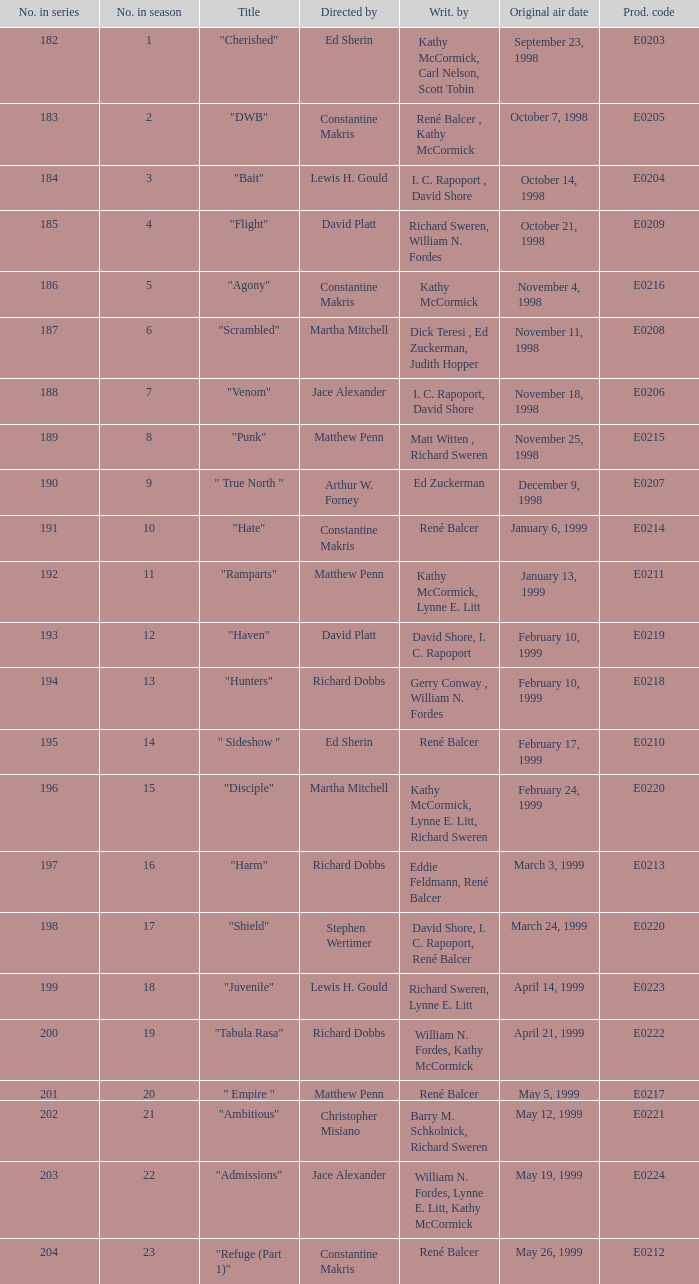The episode with original air date January 13, 1999 is written by who? Kathy McCormick, Lynne E. Litt. 